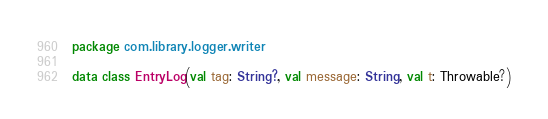<code> <loc_0><loc_0><loc_500><loc_500><_Kotlin_>package com.library.logger.writer

data class EntryLog(val tag: String?, val message: String, val t: Throwable?)</code> 